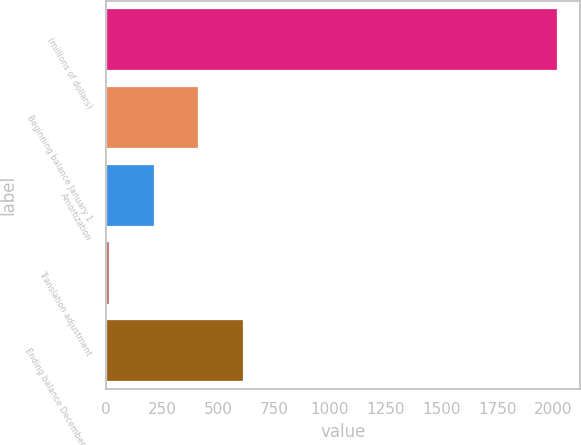Convert chart to OTSL. <chart><loc_0><loc_0><loc_500><loc_500><bar_chart><fcel>(millions of dollars)<fcel>Beginning balance January 1<fcel>Amortization<fcel>Translation adjustment<fcel>Ending balance December 31<nl><fcel>2018<fcel>412.72<fcel>212.06<fcel>11.4<fcel>613.38<nl></chart> 